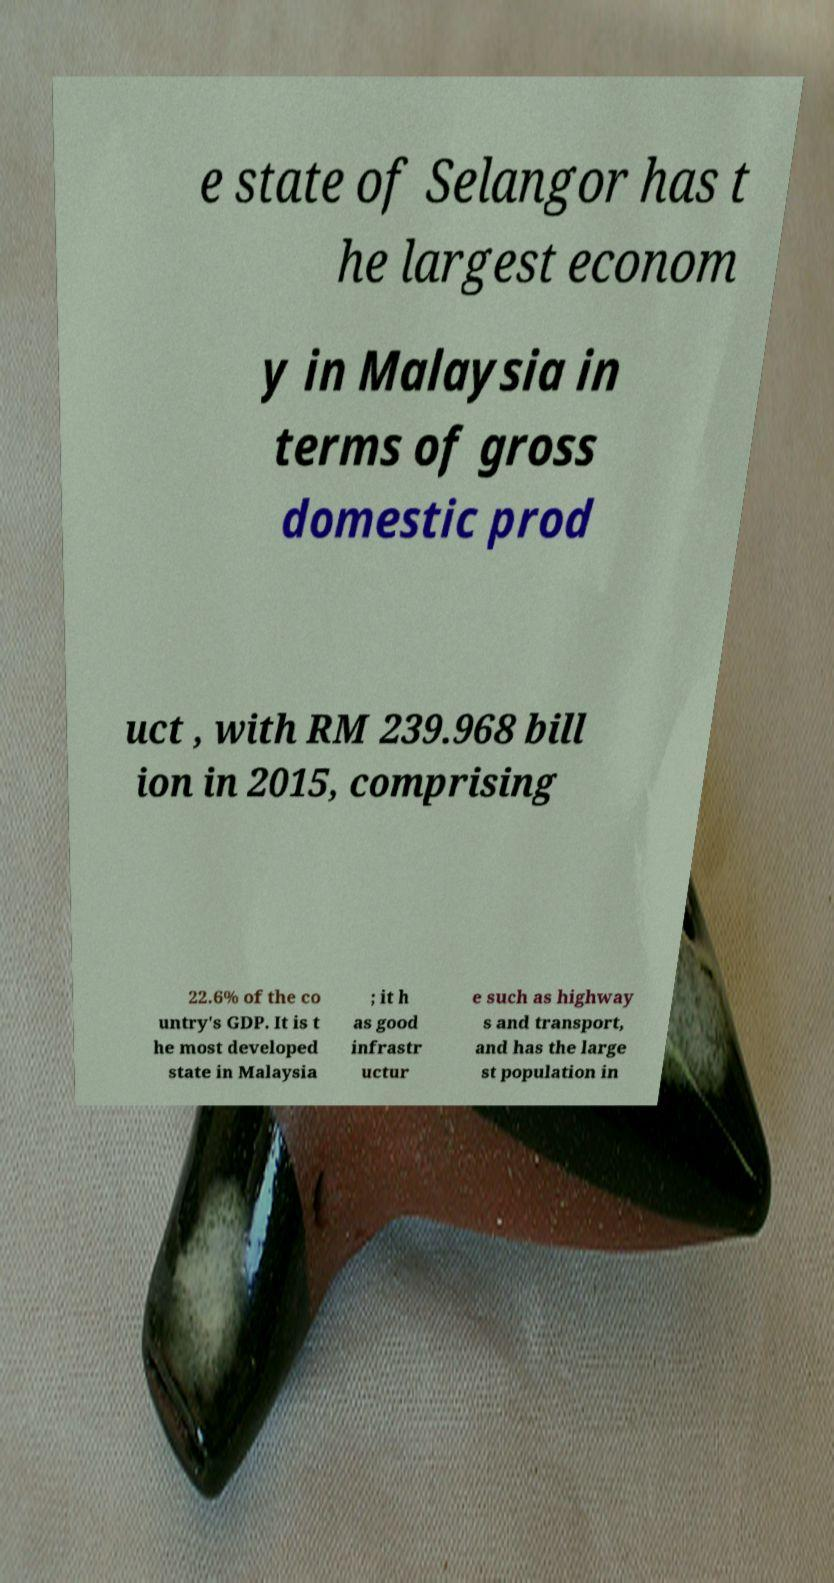Could you extract and type out the text from this image? e state of Selangor has t he largest econom y in Malaysia in terms of gross domestic prod uct , with RM 239.968 bill ion in 2015, comprising 22.6% of the co untry's GDP. It is t he most developed state in Malaysia ; it h as good infrastr uctur e such as highway s and transport, and has the large st population in 